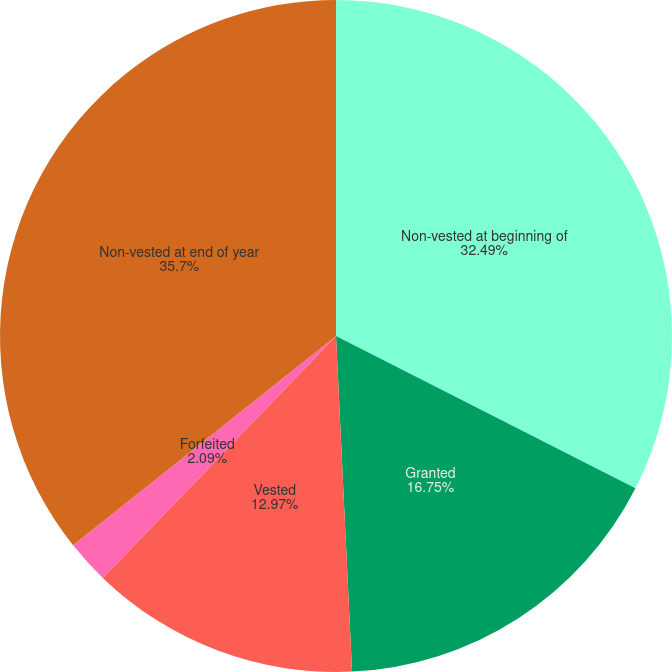<chart> <loc_0><loc_0><loc_500><loc_500><pie_chart><fcel>Non-vested at beginning of<fcel>Granted<fcel>Vested<fcel>Forfeited<fcel>Non-vested at end of year<nl><fcel>32.49%<fcel>16.75%<fcel>12.97%<fcel>2.09%<fcel>35.7%<nl></chart> 